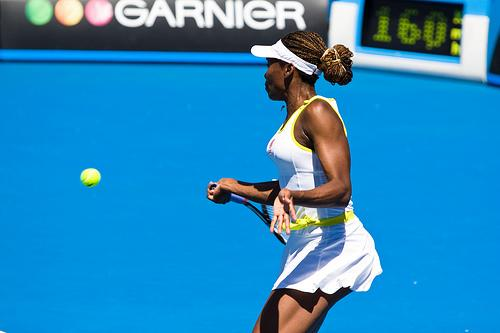What is the color of the wall in the background? The wall in the background is blue. Describe the tennis player's appearance in the image. The woman has her hair in a bun, wearing a white tennis outfit with yellow trim, a white visor, and holding a tennis racket. Mention any distinctive features of the tennis player's outfit. The tennis player's outfit includes a white tank top trimmed in yellow and a white tennis skirt. Identify an important aspect of the tennis player's hairstyle. The tennis player has her hair styled in a bun. What color is the tennis outfit the woman is wearing? The woman is wearing a white tennis outfit with yellow trim. What is the tennis player wearing on her head? The tennis player is wearing a white visor on her head. Briefly explain the scenery of the image. In the image, a woman plays tennis with a blue wall behind her and a billboard sign in the background. Mention the primary activity happening in the image. A woman is playing tennis, swinging her racket at a ball in the air. Describe the ball that is present in the image. The tennis ball is yellow and is in the air during the game. Can you describe the woman's tennis racket? The woman is holding a tennis racket in her right hand, ready to hit the ball. 